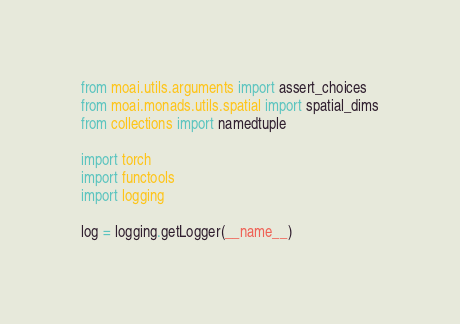Convert code to text. <code><loc_0><loc_0><loc_500><loc_500><_Python_>from moai.utils.arguments import assert_choices
from moai.monads.utils.spatial import spatial_dims
from collections import namedtuple

import torch
import functools
import logging

log = logging.getLogger(__name__)
</code> 